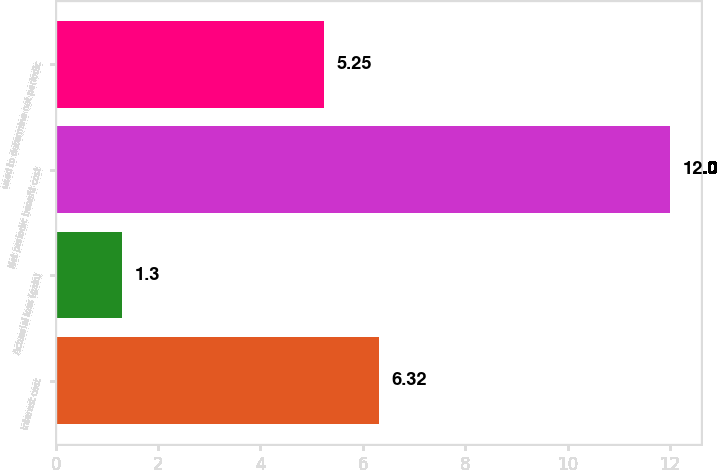<chart> <loc_0><loc_0><loc_500><loc_500><bar_chart><fcel>Interest cost<fcel>Actuarial loss (gain)<fcel>Net periodic benefit cost<fcel>used to determine net periodic<nl><fcel>6.32<fcel>1.3<fcel>12<fcel>5.25<nl></chart> 